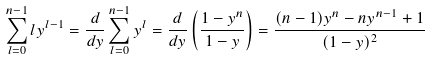Convert formula to latex. <formula><loc_0><loc_0><loc_500><loc_500>\sum _ { l = 0 } ^ { n - 1 } l y ^ { l - 1 } = \frac { d } { d y } \sum _ { l = 0 } ^ { n - 1 } y ^ { l } = \frac { d } { d y } \left ( \frac { 1 - y ^ { n } } { 1 - y } \right ) = \frac { ( n - 1 ) y ^ { n } - n y ^ { n - 1 } + 1 } { ( 1 - y ) ^ { 2 } }</formula> 